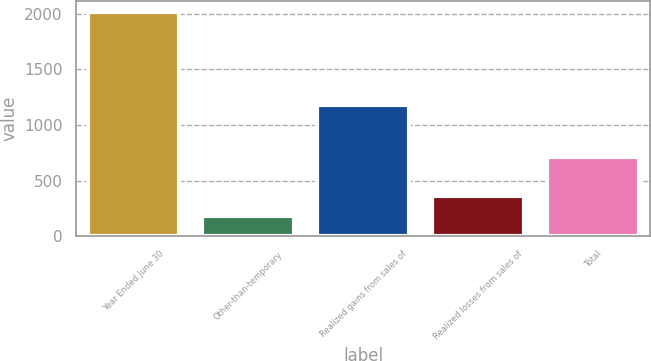Convert chart. <chart><loc_0><loc_0><loc_500><loc_500><bar_chart><fcel>Year Ended June 30<fcel>Other-than-temporary<fcel>Realized gains from sales of<fcel>Realized losses from sales of<fcel>Total<nl><fcel>2015<fcel>183<fcel>1176<fcel>366.2<fcel>716<nl></chart> 